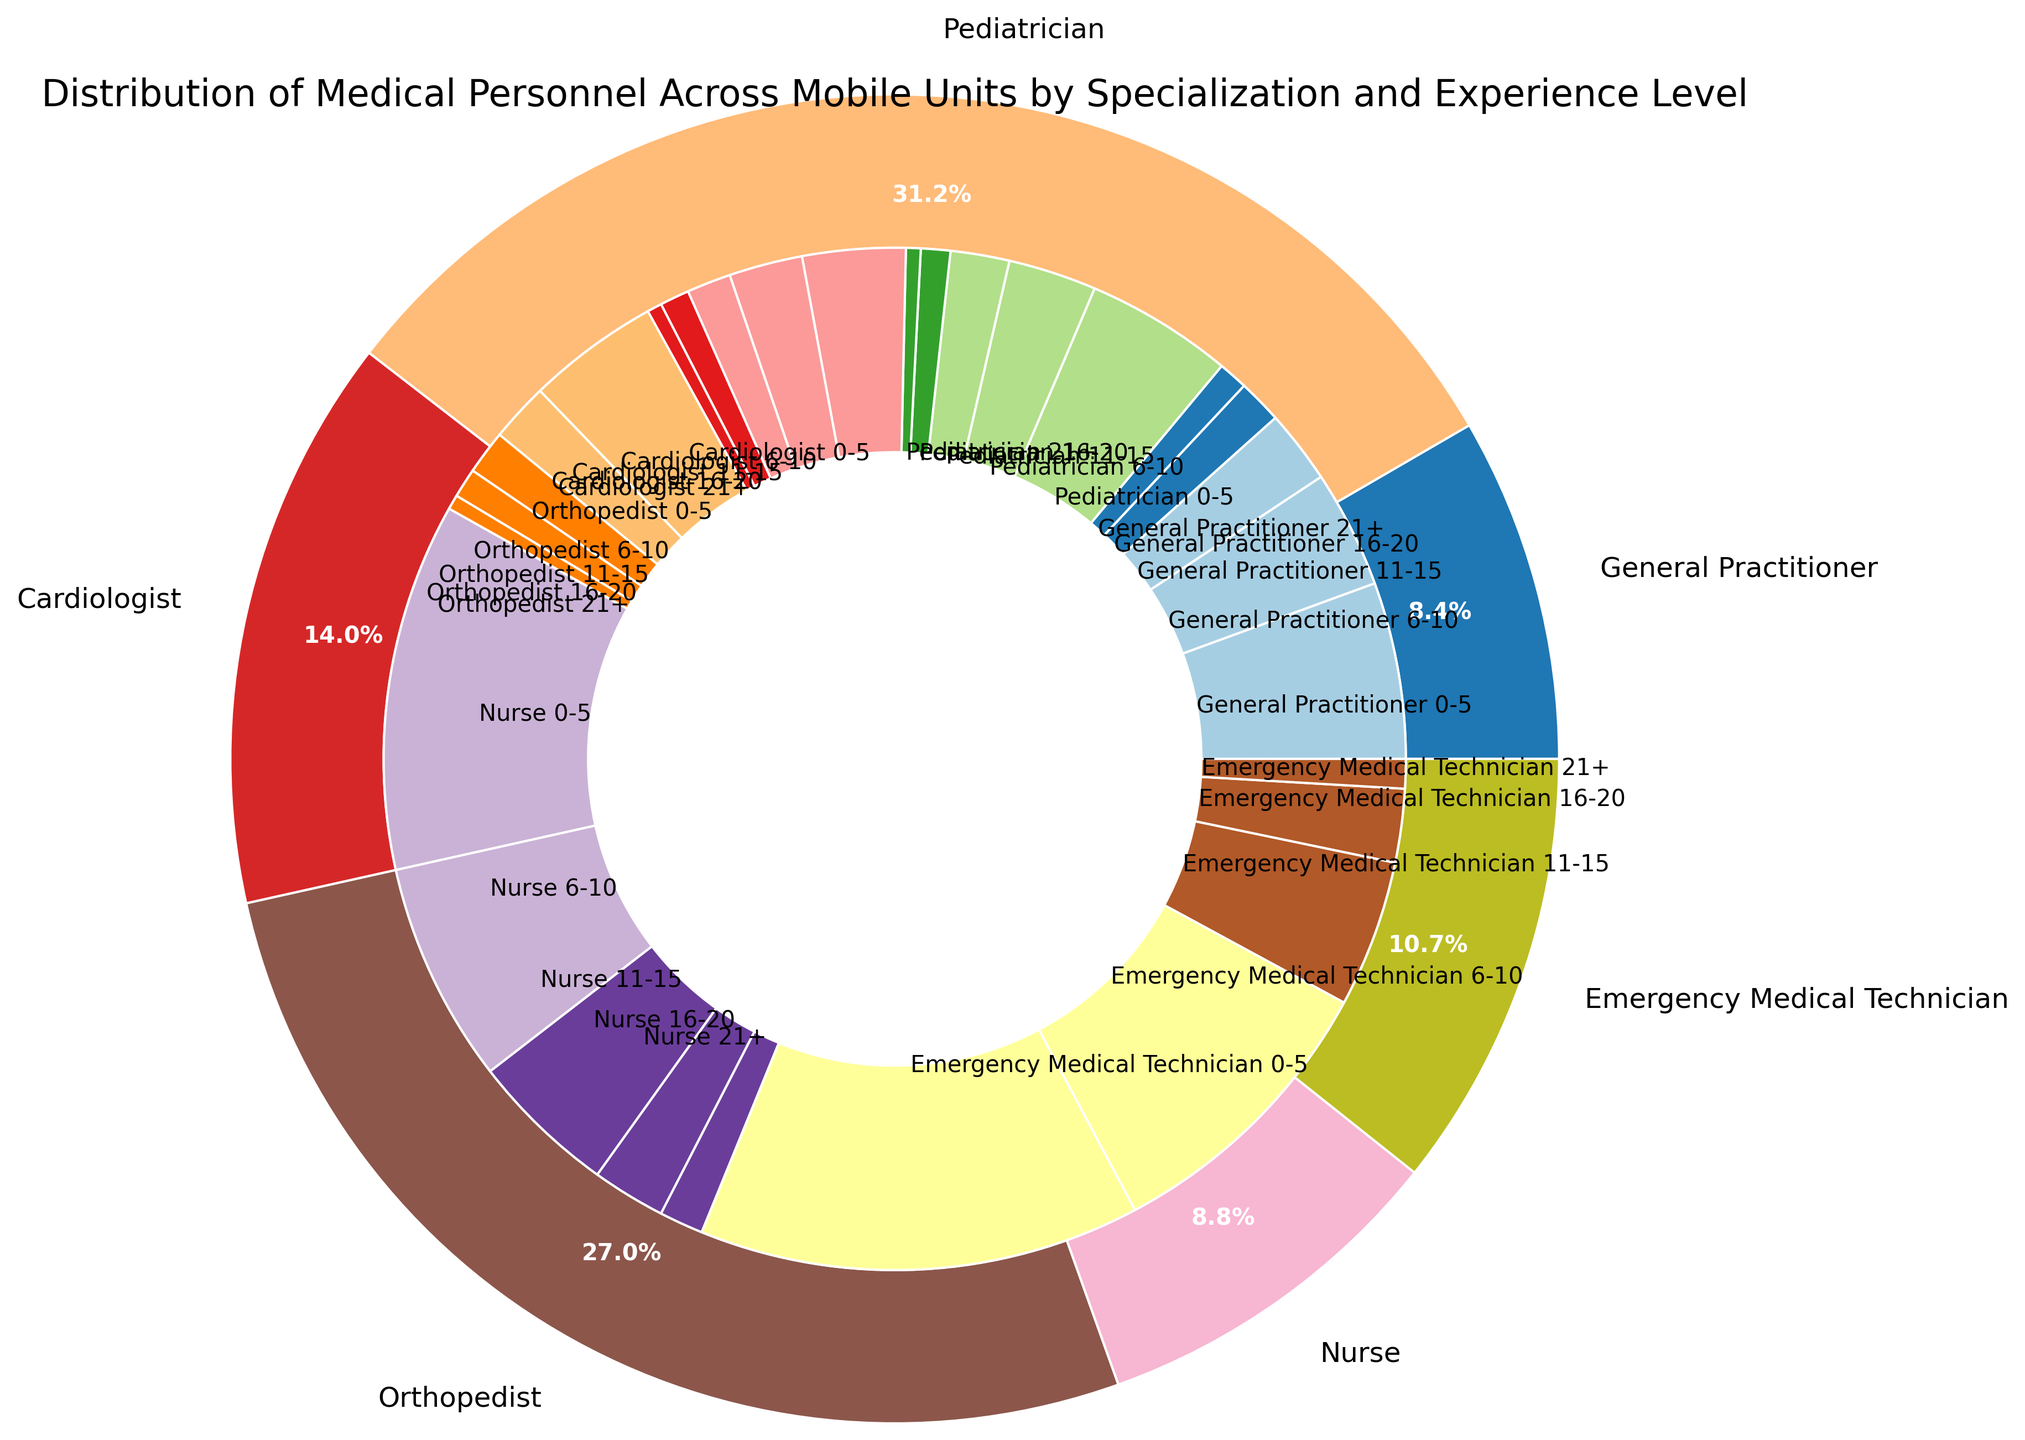What specialization has the highest number of medical personnel? Look at the outer pie chart and identify the slice with the largest size. The largest slice represents the Emergency Medical Technician specialization.
Answer: Emergency Medical Technician Which specialization has more personnel with 0-5 years of experience, Pediatricians or Orthopedists? Compare the inner slices labeled "Pediatrician 0-5" and "Orthopedist 0-5". The "Pediatrician 0-5" slice has 10 personnel, while the "Orthopedist 0-5" slice has 9.
Answer: Pediatricians Are there more General Practitioners or Cardiologists with 11-15 years of experience? Locate the "General Practitioner 11-15" and "Cardiologist 11-15" slices in the inner pie chart. There are 5 General Practitioners and 3 Cardiologists within this experience range.
Answer: General Practitioners What is the combined number of personnel with 21+ years of experience across all specializations? Add the counts from each specialization for the 21+ years experience category: 2 (General Practitioner) + 1 (Pediatrician) + 1 (Cardiologist) + 1 (Orthopedist) + 3 (Nurse) + 2 (Emergency Medical Technician) = 10
Answer: 10 Which specialization has the smallest combined count of personnel? Look at the outer pie chart and identify the smallest slice. Cardiologists have the smallest combined count.
Answer: Cardiologists Which specialization has the highest percentage of personnel with less than 16 years of experience? Break down each specialization into 0-5, 6-10, and 11-15 years categories, and then compare. Emergency Medical Technicians have the highest number of personnel within these ranges combined (30 + 20 + 10 = 60).
Answer: Emergency Medical Technicians Which specialization has the largest difference in the number of personnel between the 0-5 and 6-10 years of experience categories? Calculate the differences for each specialization: General Practitioner (12-8=4), Pediatricians (10-6=4), Cardiologists (7-5=2), Orthopedists (9-4=5), Nurses (25-15=10), Emergency Medical Technicians (30-20=10).
Answer: Nurses and Emergency Medical Technicians What is the general trend for personnel numbers as experience level increases within each specialization? Observe the inner slices of each specialization and see how the size of each pie slice changes with increasing experience levels. The trend is generally a decrease in personnel numbers as experience level increases across all specializations.
Answer: Decreasing 